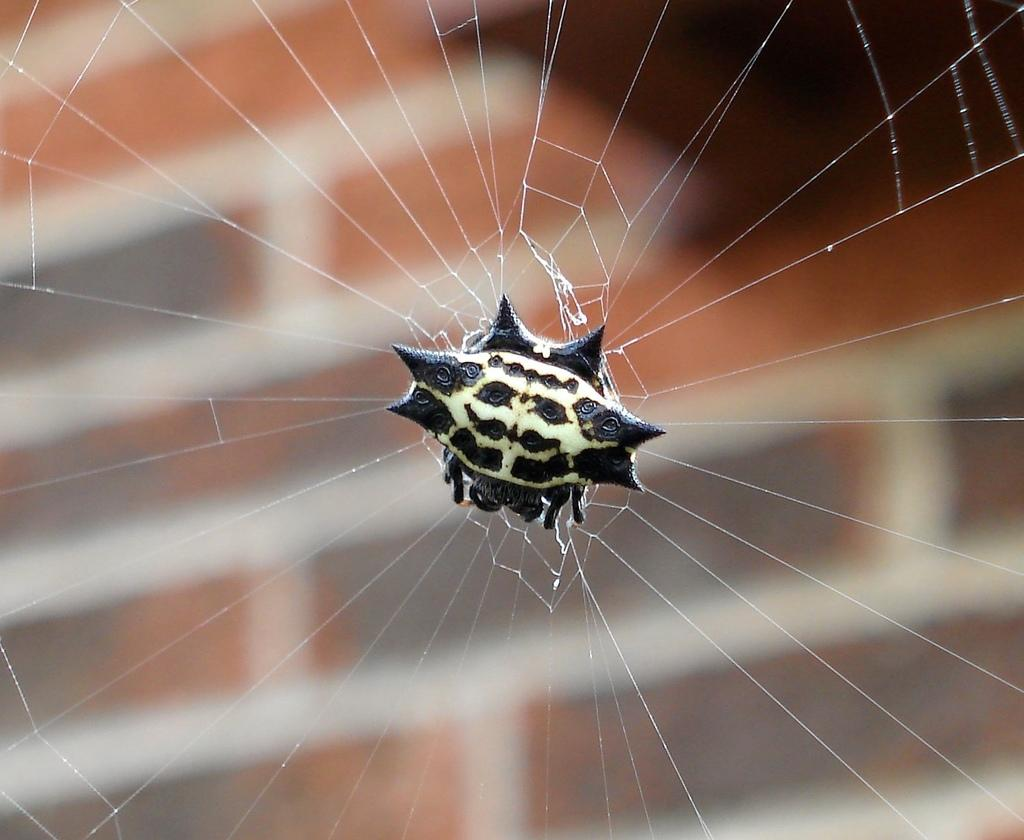What is the main subject of the image? The main subject of the image is a spider. What is the spider associated with in the image? There is a spider web in the image. What type of insurance policy is the spider considering in the image? There is no indication in the image that the spider is considering any insurance policy. What type of calculator is the spider using to solve math problems in the image? There is no calculator present in the image, and spiders do not use calculators. 